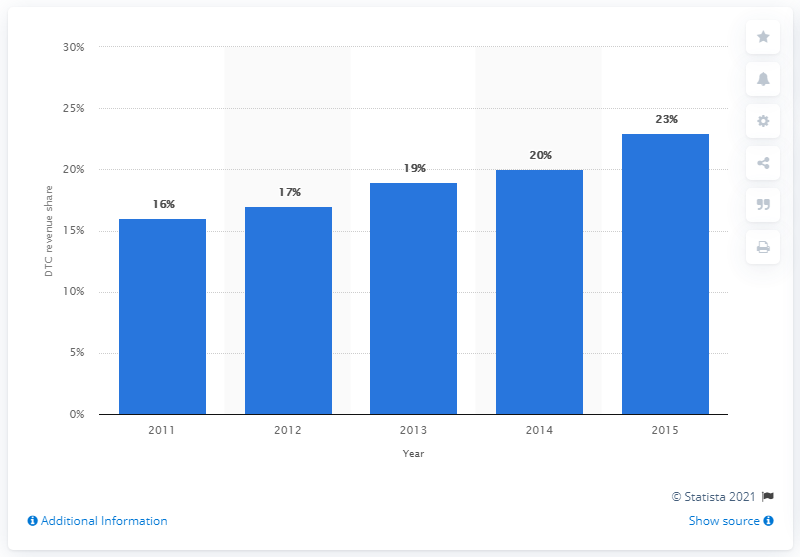Highlight a few significant elements in this photo. In 2015, Nike's direct-to-consumer revenue accounted for approximately 23% of the company's total revenue. 